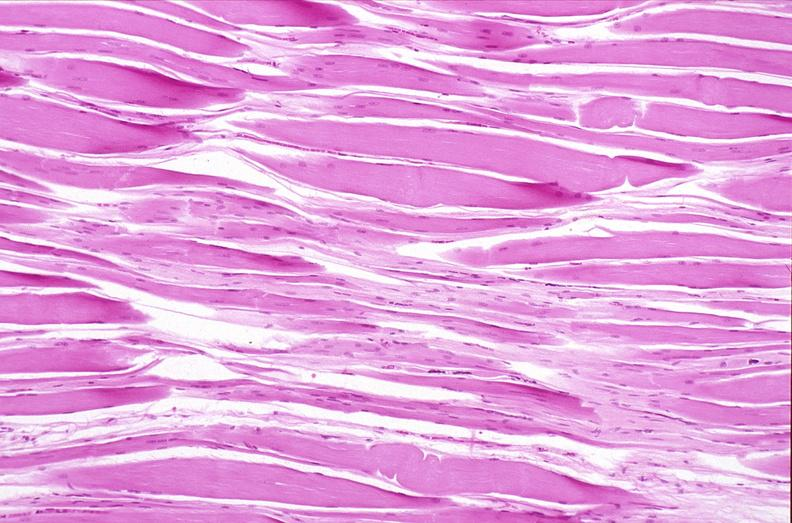what is present?
Answer the question using a single word or phrase. Musculoskeletal 